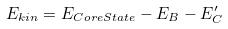<formula> <loc_0><loc_0><loc_500><loc_500>E _ { k i n } = E _ { C o r e S t a t e } - E _ { B } - E _ { C } ^ { \prime }</formula> 